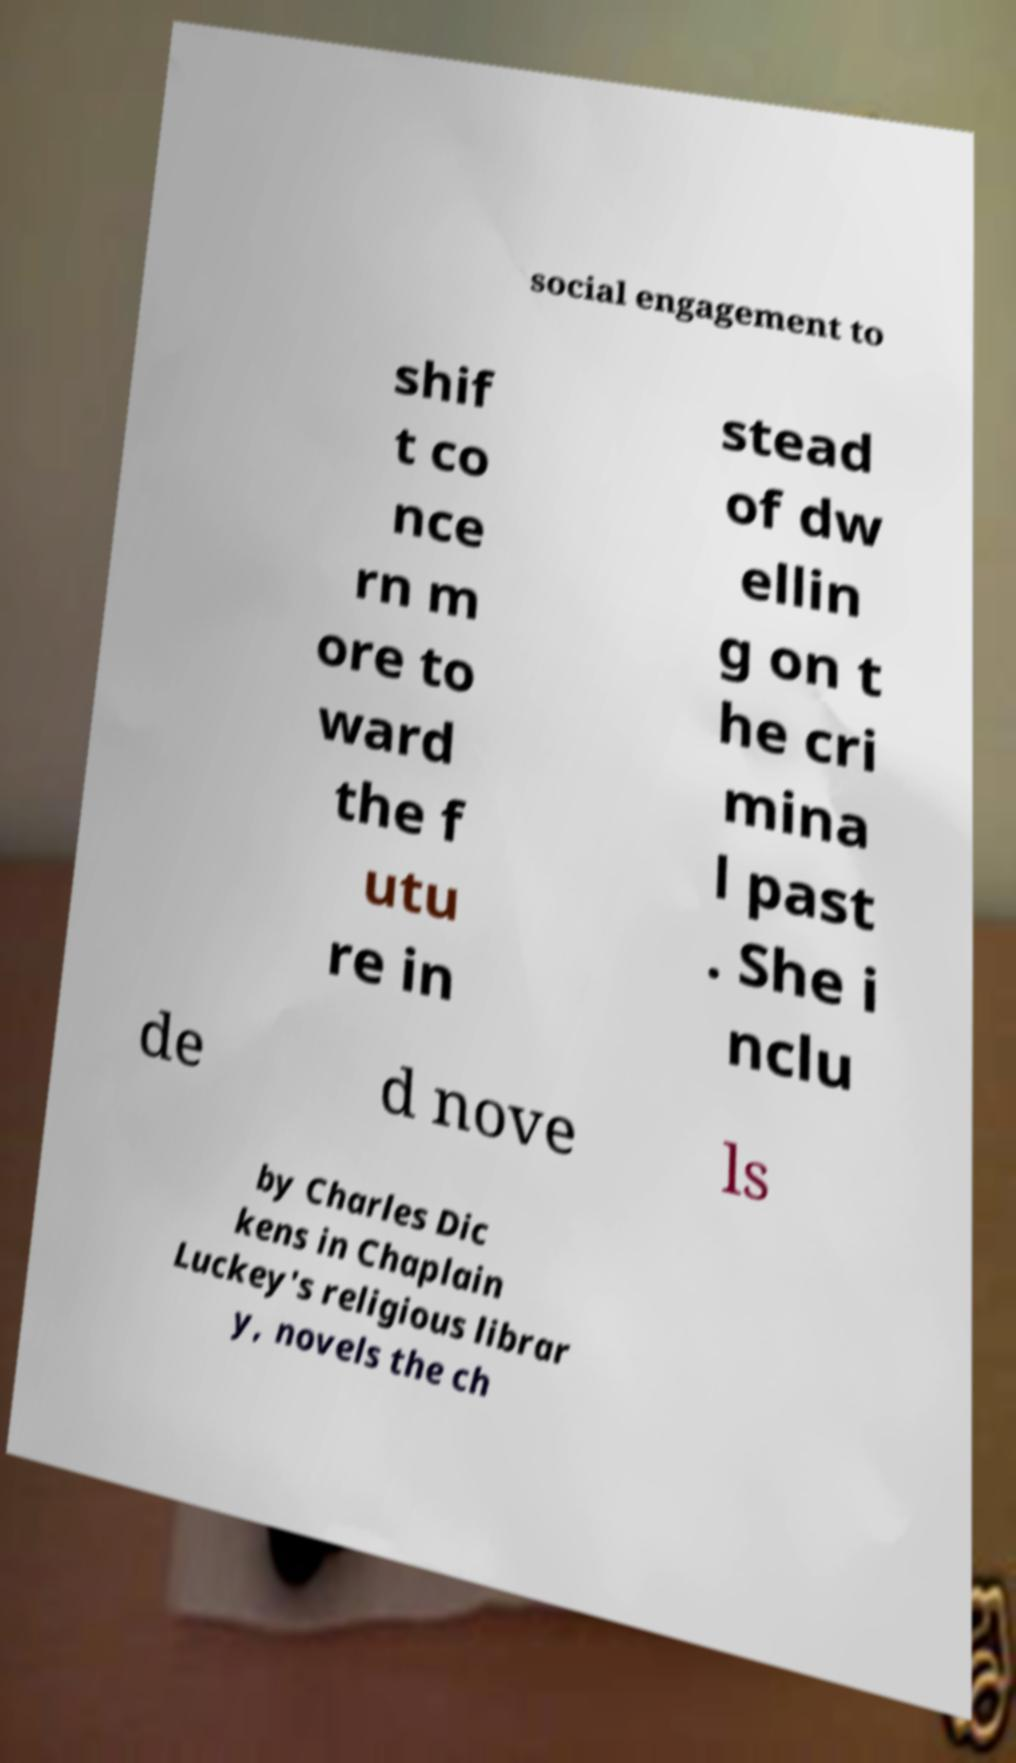I need the written content from this picture converted into text. Can you do that? social engagement to shif t co nce rn m ore to ward the f utu re in stead of dw ellin g on t he cri mina l past . She i nclu de d nove ls by Charles Dic kens in Chaplain Luckey's religious librar y, novels the ch 